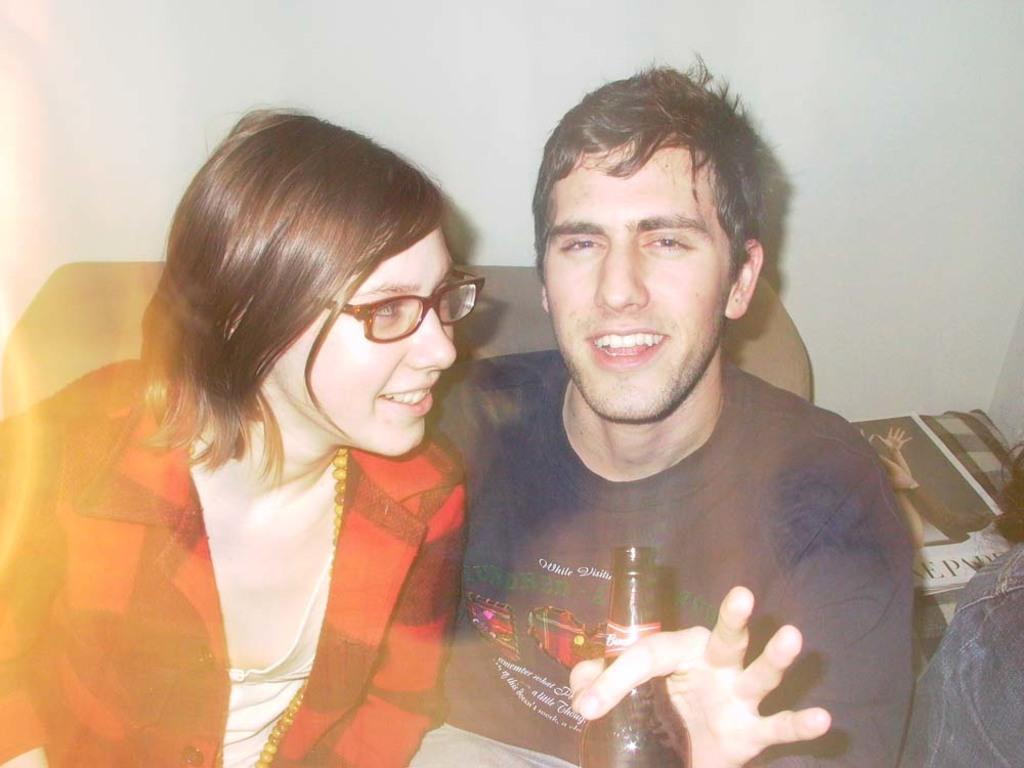Can you describe this image briefly? In this image there are two persons a woman and man at the left side of the image there is a woman wearing red color shirt and at the right side of the image there is man wearing T-shirt holding a beer bottle in his hand. 